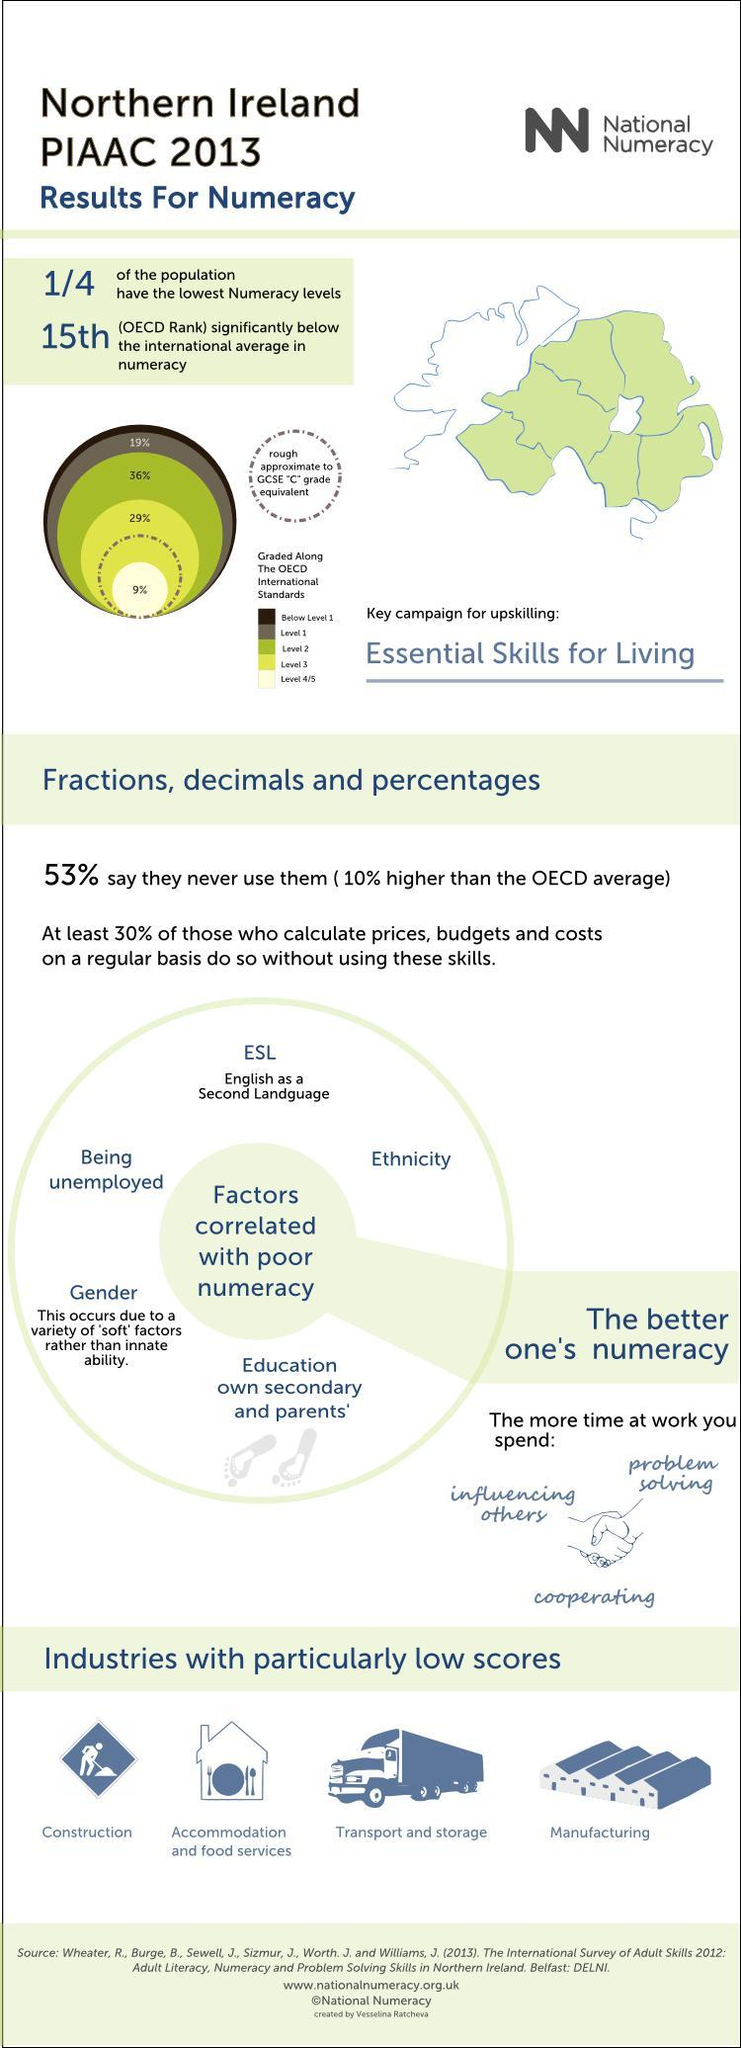how may industries have particularly low score
Answer the question with a short phrase. 4 what has 53% never used fractions, decimals and percentages what percentage of the population have the lowerst numeracy levels 25 What percentage is at level 2 36% what is the ranking of Northers Ireland 15th 